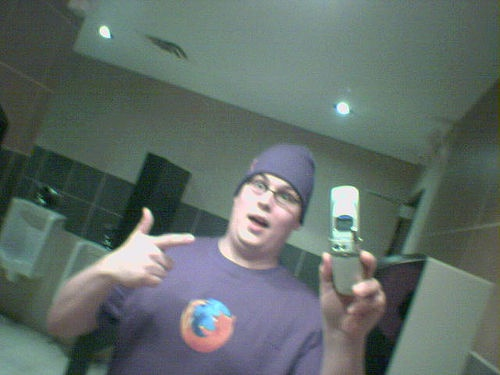Describe the objects in this image and their specific colors. I can see people in darkgreen, gray, and lightgray tones, toilet in darkgreen and teal tones, cell phone in darkgreen, ivory, gray, and darkgray tones, and toilet in darkgreen, teal, and gray tones in this image. 